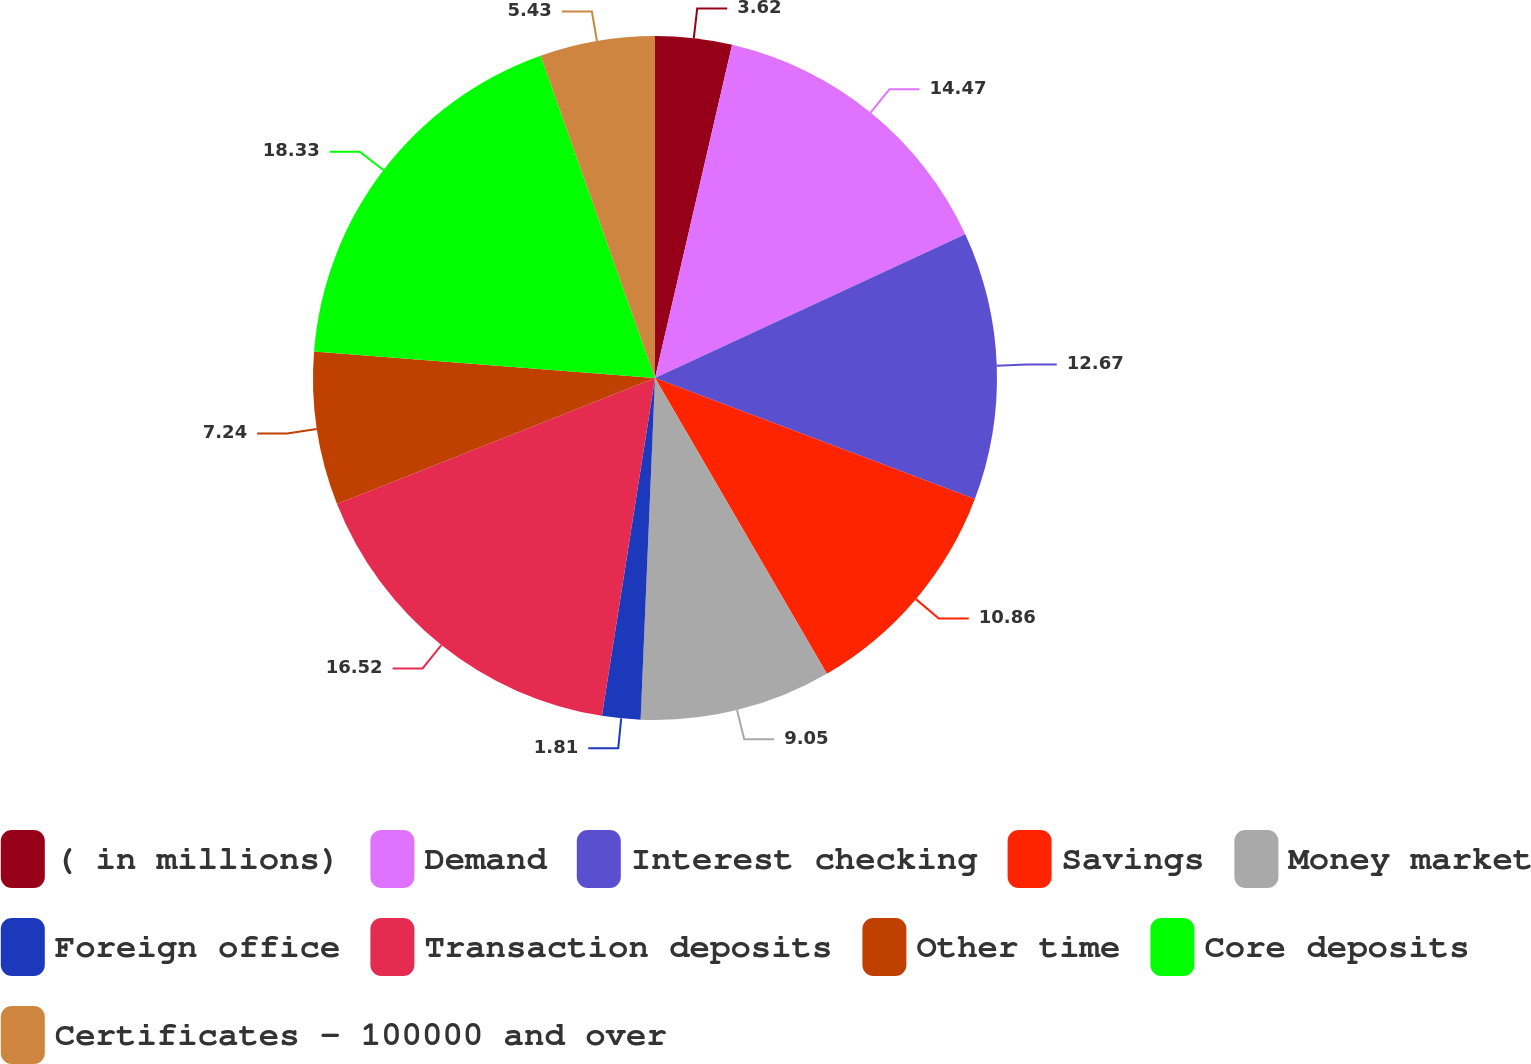Convert chart to OTSL. <chart><loc_0><loc_0><loc_500><loc_500><pie_chart><fcel>( in millions)<fcel>Demand<fcel>Interest checking<fcel>Savings<fcel>Money market<fcel>Foreign office<fcel>Transaction deposits<fcel>Other time<fcel>Core deposits<fcel>Certificates - 100000 and over<nl><fcel>3.62%<fcel>14.47%<fcel>12.67%<fcel>10.86%<fcel>9.05%<fcel>1.81%<fcel>16.52%<fcel>7.24%<fcel>18.33%<fcel>5.43%<nl></chart> 